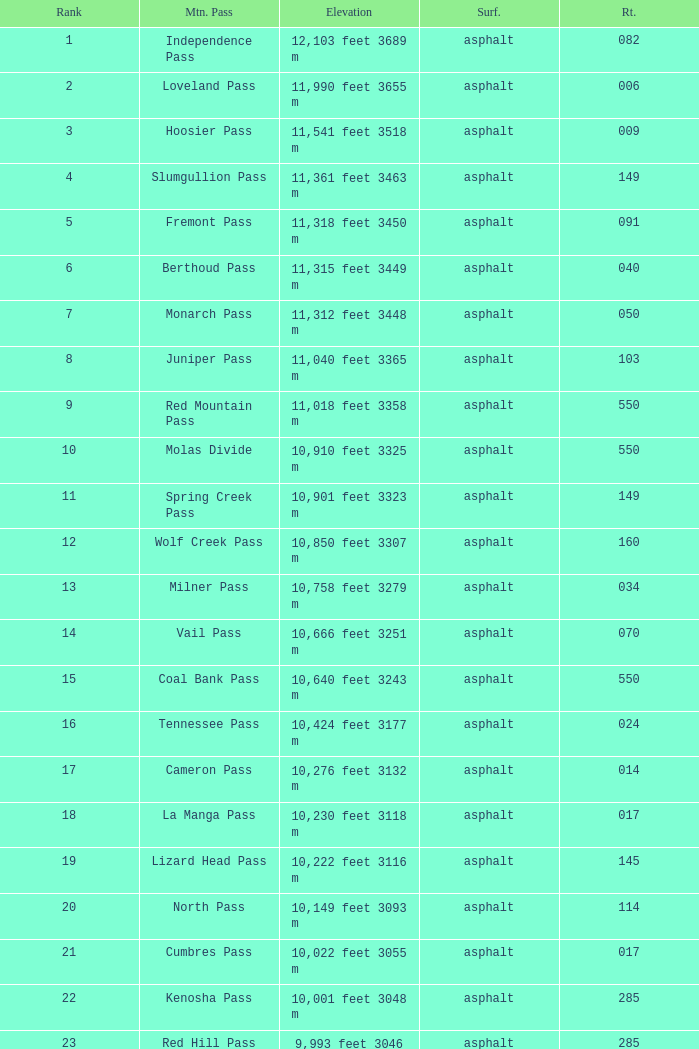What is the Mountain Pass with a 21 Rank? Cumbres Pass. 